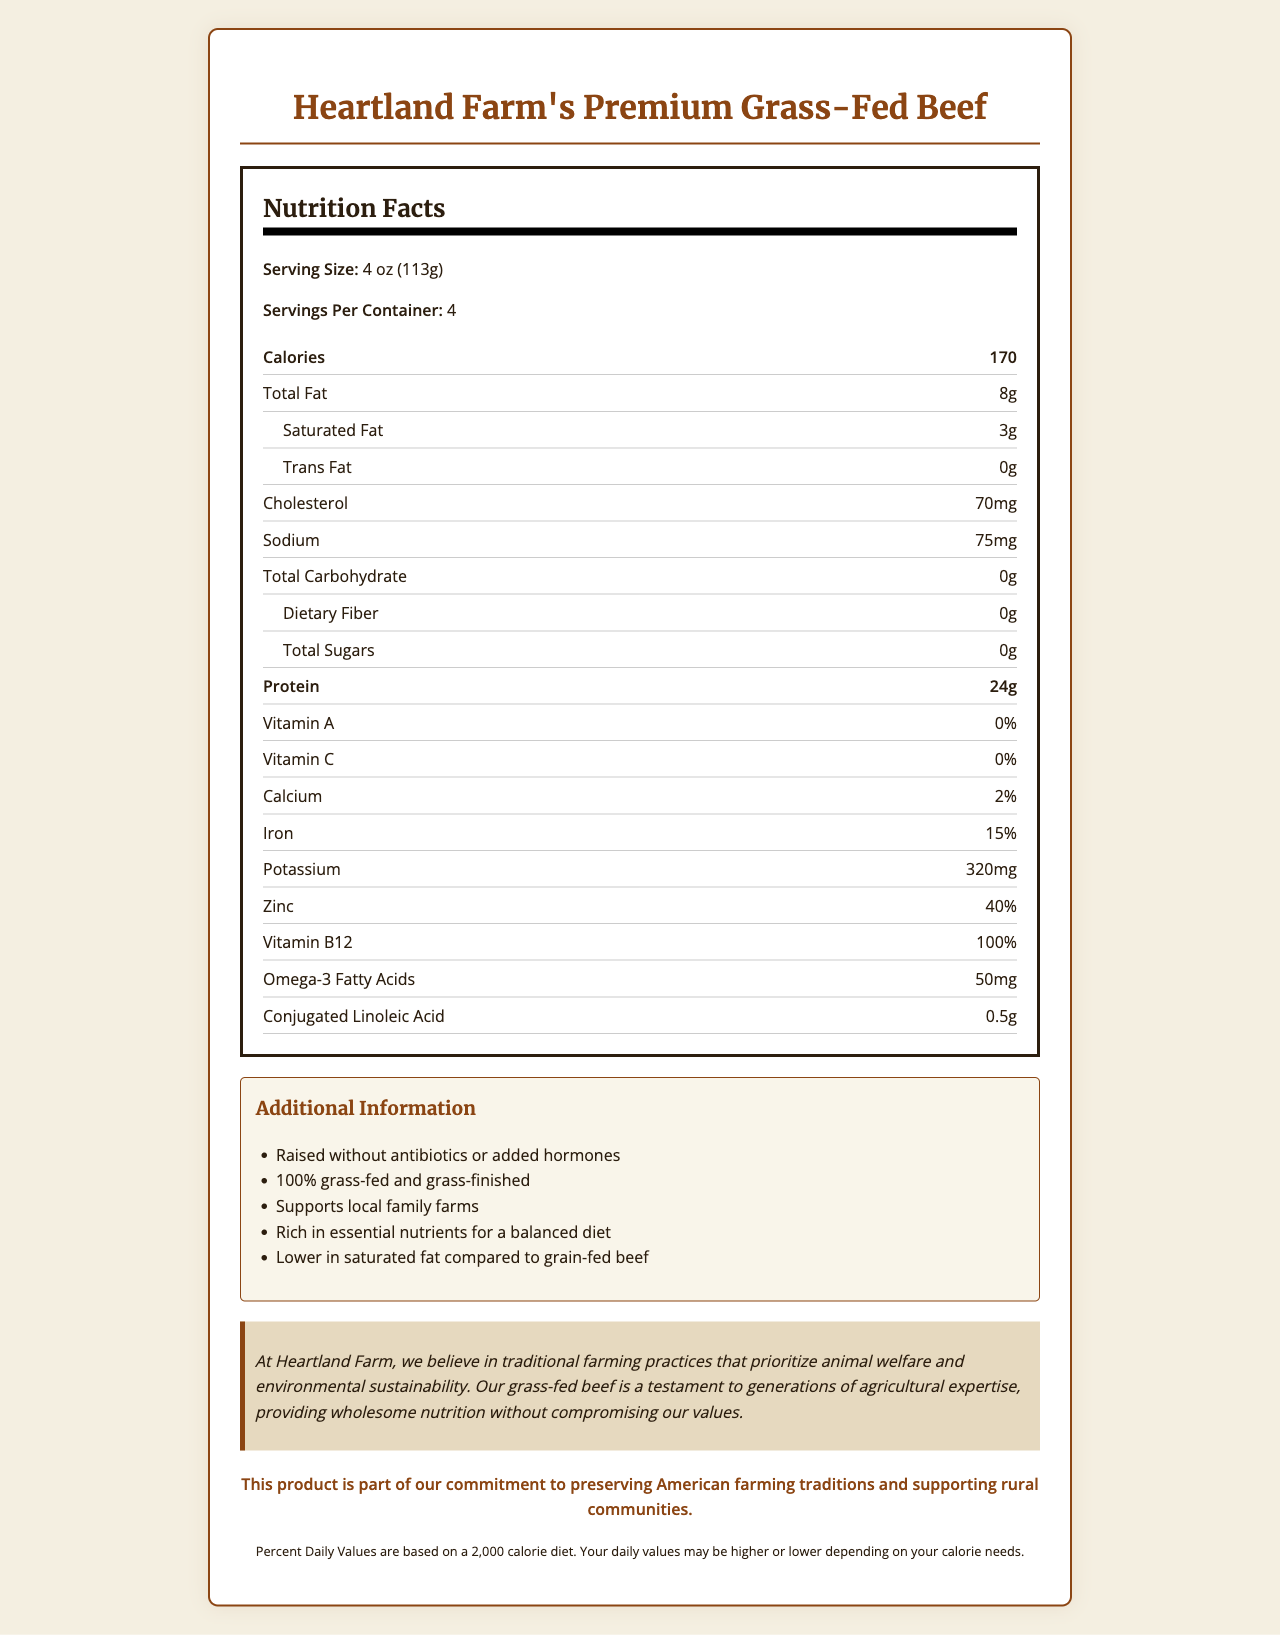What is the serving size of Heartland Farm's Premium Grass-Fed Beef? The serving size is clearly listed as 4 oz (113g) in the Nutrition Facts section.
Answer: 4 oz (113g) How many grams of protein are there in one serving? The Nutrition Facts label states that one serving contains 24g of protein.
Answer: 24g What is the total fat content per serving? According to the Nutrition Facts label, the total fat per serving is 8g.
Answer: 8g How many servings are there per container? The label shows that there are 4 servings per container.
Answer: 4 How much sodium is in one serving? The Nutrition Facts state that there is 75mg of sodium per serving.
Answer: 75mg Does this product contain any trans fat? The label indicates that there is 0g of trans fat per serving.
Answer: No Which vitamin has the highest percentage daily value? A. Vitamin A B. Vitamin C C. Vitamin B12 D. Calcium Vitamin B12 has a daily value of 100%, which is the highest among the listed vitamins.
Answer: C. Vitamin B12 Which of the following statements is true about Heartland Farm's Premium Grass-Fed Beef? I. It is raised without antibiotics or added hormones II. It is rich in essential nutrients for a balanced diet III. It contains high levels of saturated fat The label mentions it is raised without antibiotics or added hormones and is rich in essential nutrients, but it mentions it is lower in saturated fat.
Answer: I and II Is the product lower in saturated fat compared to grain-fed beef? The additional information section confirms that this product is lower in saturated fat compared to grain-fed beef.
Answer: Yes Summarize the main nutritional benefits and farm practices of Heartland Farm's Premium Grass-Fed Beef. The document highlights the nutritional advantages such as high protein and low saturated fat compared to grain-fed beef, and details the traditional and sustainable farming practices employed by Heartland Farm, along with their commitment to animal welfare and support for rural communities.
Answer: Heartland Farm's Premium Grass-Fed Beef provides high protein content of 24g per serving and is lower in saturated fat compared to grain-fed beef. It is raised without antibiotics or added hormones, supports local family farms, and is rich in essential nutrients. The product also emphasizes traditional farming practices and environmental sustainability. How many mg of potassium does one serving contain? The Nutrition Facts specify that one serving contains 320mg of potassium.
Answer: 320mg What percentage of the daily value of iron does one serving provide? The Nutrition Facts label states that one serving provides 15% of the daily value of iron.
Answer: 15% What is the total carbohydrate content per serving? According to the Nutrition Facts, the total carbohydrate content per serving is 0g.
Answer: 0g What is the farm statement associated with this product? The farm statement is clearly listed in the document emphasizing their belief in traditional farming practices, animal welfare, and environmental sustainability.
Answer: "At Heartland Farm, we believe in traditional farming practices that prioritize animal welfare and environmental sustainability. Our grass-fed beef is a testament to generations of agricultural expertise, providing wholesome nutrition without compromising our values." What is the omega-3 fatty acid content in one serving? The Nutrition Facts label indicates that one serving contains 50mg of omega-3 fatty acids.
Answer: 50mg Does the document provide information on how many grams of dietary fiber are in one serving? The Nutrition Facts label lists 0g of dietary fiber per serving.
Answer: Yes Is the beef grass-fed and grass-finished? The additional information section confirms that the beef is 100% grass-fed and grass-finished.
Answer: Yes What methods were used to raise this beef? The additional information section specifies that the beef is raised without antibiotics or added hormones.
Answer: Raised without antibiotics or added hormones How many grams of conjugated linoleic acid does one serving contain? The Nutrition Facts indicate that one serving contains 0.5g of conjugated linoleic acid.
Answer: 0.5g What specific nutrients are emphasized in the document for a balanced diet? The document highlights essential nutrients such as protein (24g), iron (15% DV), potassium (320mg), zinc (40% DV), vitamin B12 (100% DV), and omega-3 fatty acids (50mg).
Answer: Essential nutrients like protein, iron, potassium, zinc, vitamin B12, and omega-3 fatty acids What is the percentage of daily value of calcium in one serving? The Nutrition Facts label shows that one serving provides 2% of the daily value of calcium.
Answer: 2% How many calories are there in one serving? The Nutrition Facts state that one serving contains 170 calories.
Answer: 170 Can this document tell you the exact farming methods used for raising the cattle? The document emphasizes traditional farming practices and animal welfare but does not provide exact details of the farming methods.
Answer: Not enough information 